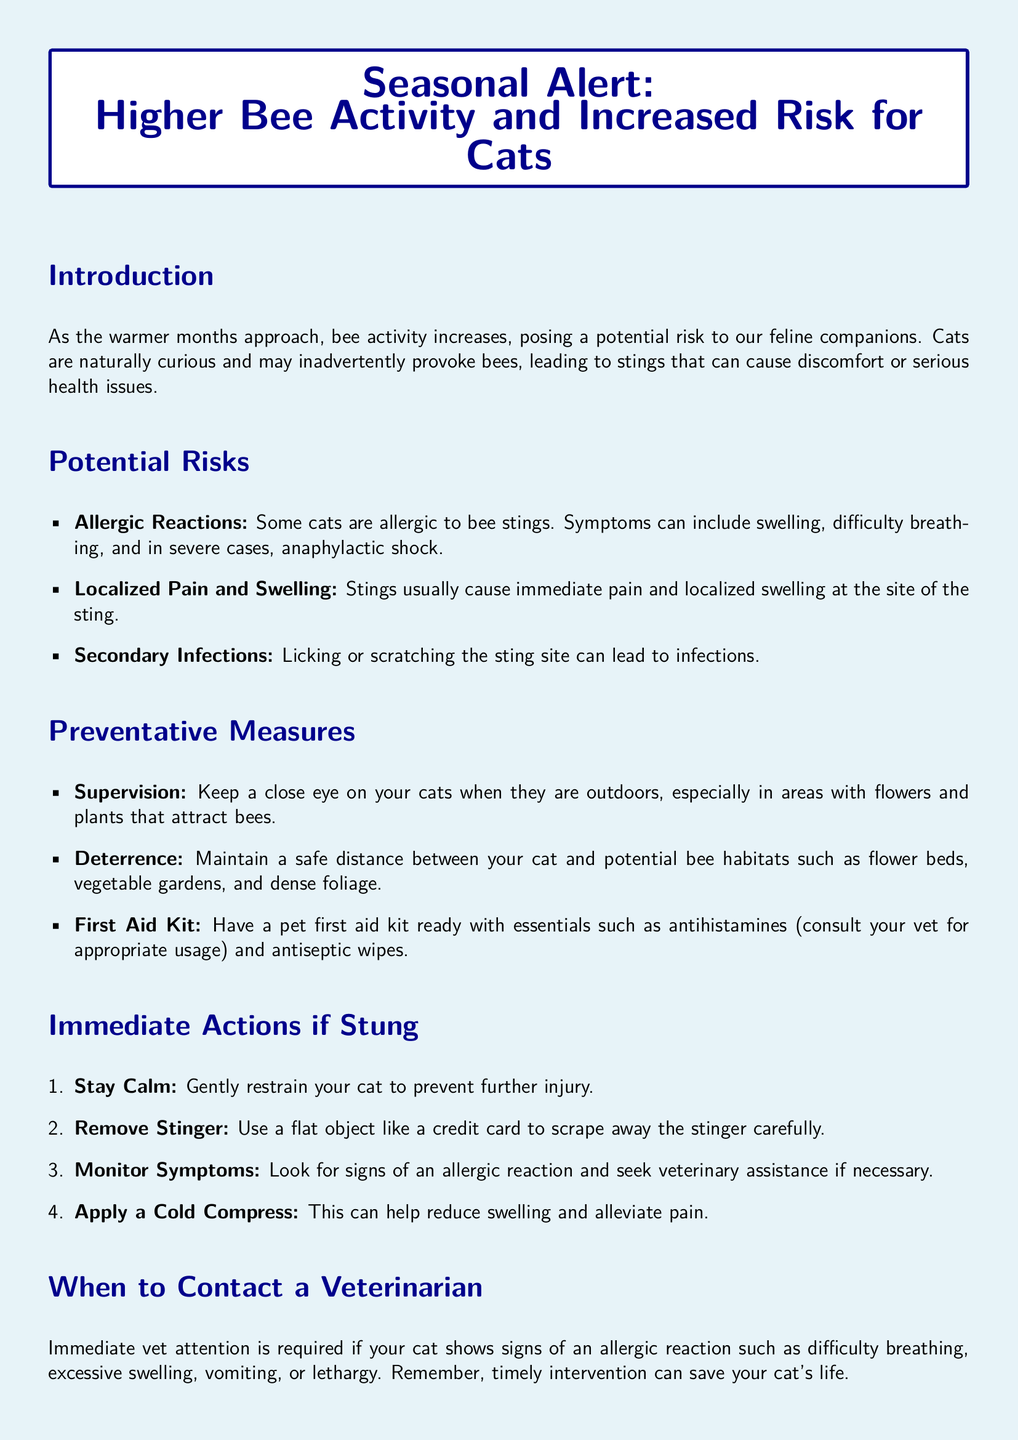what is the main topic of the document? The document is about the increased risk of bee stings for cats during the warmer months.
Answer: Higher Bee Activity and Increased Risk for Cats what are the symptoms of an allergic reaction? The document lists symptoms such as swelling and difficulty breathing in allergic reactions.
Answer: Swelling, difficulty breathing what is one potential consequence of a cat licking a sting site? The document states that licking or scratching the sting site can lead to infections.
Answer: Infections what should you have ready in a pet first aid kit? The document mentions that you should have antihistamines and antiseptic wipes in a first aid kit.
Answer: Antihistamines, antiseptic wipes what is the first action to take if your cat gets stung? According to the document, the first action is to stay calm and gently restrain your cat.
Answer: Stay Calm when should you contact a veterinarian? The document indicates that you should contact a veterinarian if your cat shows signs of an allergic reaction.
Answer: Signs of an allergic reaction what is a recommendation to prevent bee stings? The document suggests keeping a close eye on your cats when they are outdoors.
Answer: Supervision what can be applied to reduce swelling after a sting? The document mentions applying a cold compress can help reduce swelling and alleviate pain.
Answer: Cold Compress 